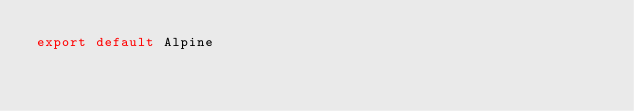Convert code to text. <code><loc_0><loc_0><loc_500><loc_500><_JavaScript_>export default Alpine
</code> 